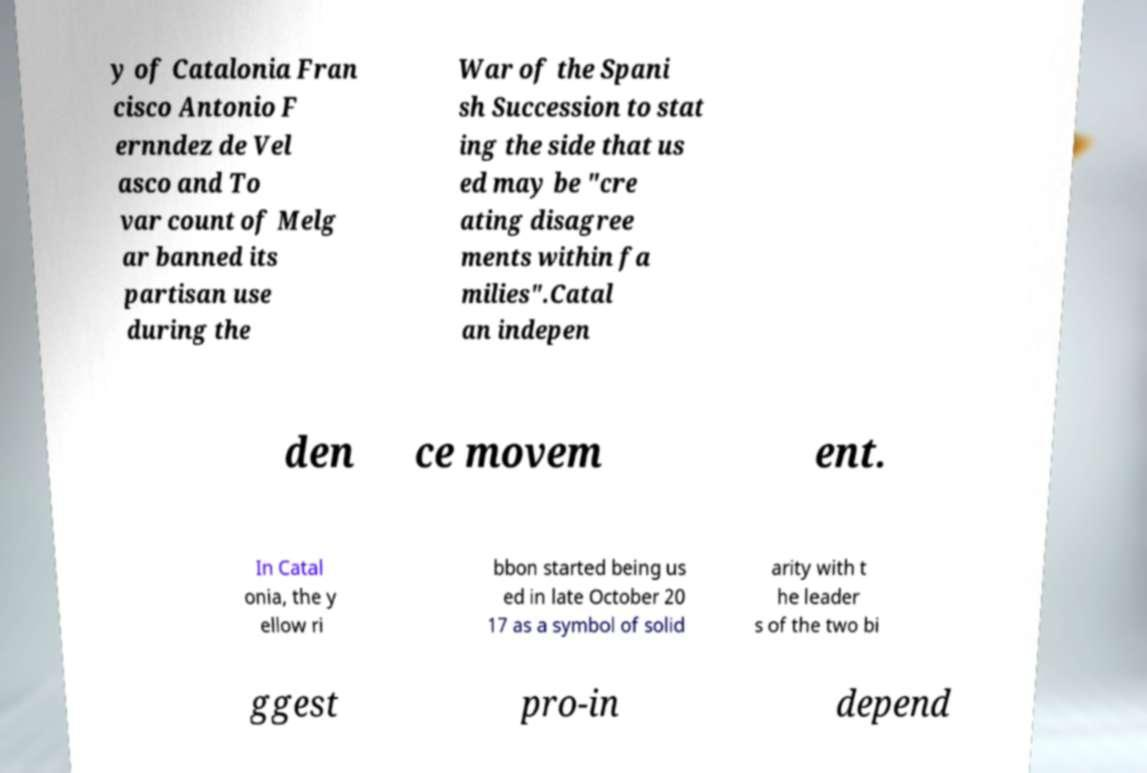Please identify and transcribe the text found in this image. y of Catalonia Fran cisco Antonio F ernndez de Vel asco and To var count of Melg ar banned its partisan use during the War of the Spani sh Succession to stat ing the side that us ed may be "cre ating disagree ments within fa milies".Catal an indepen den ce movem ent. In Catal onia, the y ellow ri bbon started being us ed in late October 20 17 as a symbol of solid arity with t he leader s of the two bi ggest pro-in depend 